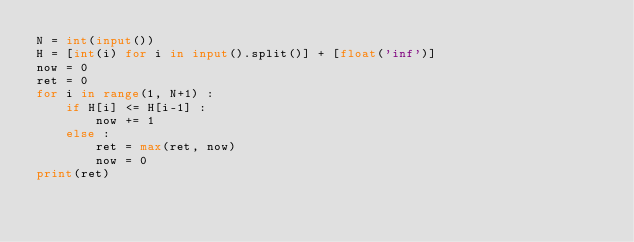<code> <loc_0><loc_0><loc_500><loc_500><_Python_>N = int(input())
H = [int(i) for i in input().split()] + [float('inf')]
now = 0
ret = 0
for i in range(1, N+1) :
    if H[i] <= H[i-1] :
        now += 1
    else :
        ret = max(ret, now)
        now = 0
print(ret)</code> 